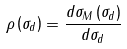Convert formula to latex. <formula><loc_0><loc_0><loc_500><loc_500>\rho \left ( \sigma _ { d } \right ) = \frac { d \sigma _ { M } \left ( \sigma _ { d } \right ) } { d \sigma _ { d } }</formula> 